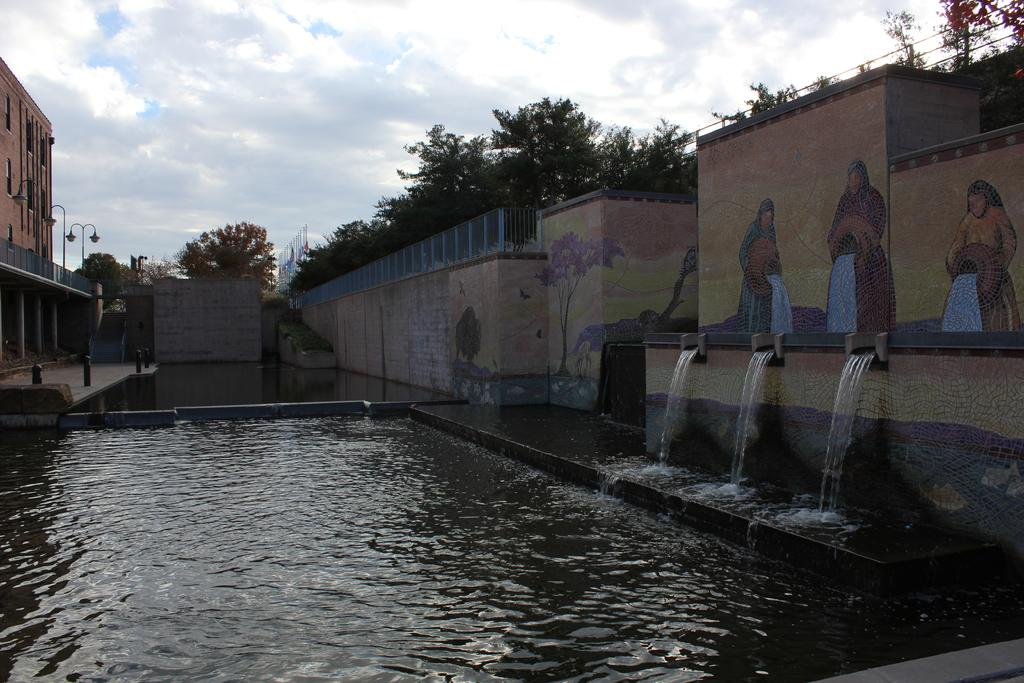What is the primary element visible in the image? There is water in the image. What can be seen on the walls in the image? There is a painting on the walls. What architectural feature is present in the image? Railings are present in the image. What type of structure is visible in the image? There is a building in the image. What are the poles used for in the image? The purpose of the poles is not specified, but they are visible in the image. What type of lighting is present in the image? Lights are present in the image. What is the purpose of the steps in the image? The steps are likely used for accessing different levels or areas in the image. What can be seen in the background of the image? Trees, objects, and the sky are visible in the background of the image. What is the weather like in the image? The presence of clouds in the sky suggests that it is a partly cloudy day. Can you see a squirrel climbing the poles in the image? There is no squirrel present in the image; only the poles, water, painting, railings, building, lights, steps, trees, objects, and sky are visible. How many dimes are scattered on the steps in the image? There is no mention of dimes in the image; only the steps, water, painting, railings, building, poles, lights, trees, objects, and sky are visible. 